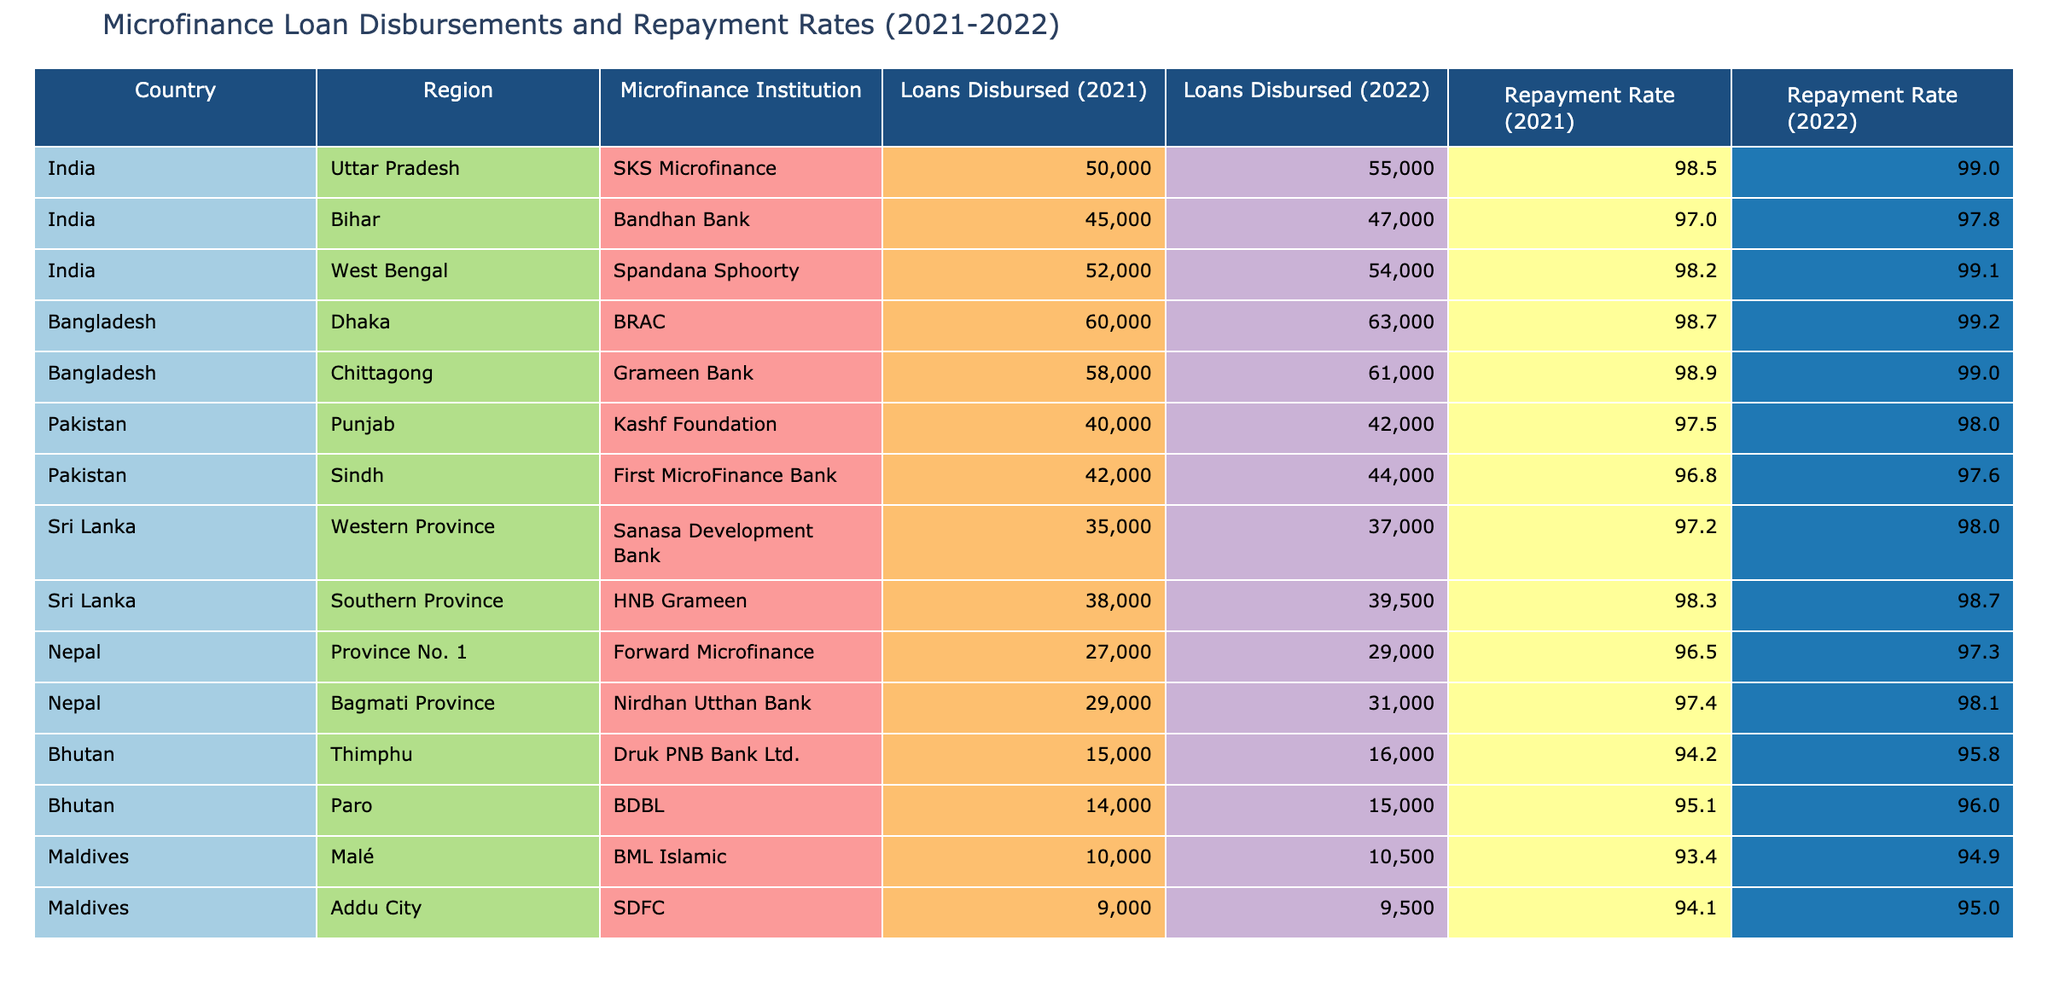What was the total amount of loans disbursed in India in 2022? To find the total amount of loans disbursed in India for 2022, we need to sum the values from the "Loans Disbursed (2022)" column for India's entries: 55,000 (Uttar Pradesh) + 47,000 (Bihar) + 54,000 (West Bengal) = 156,000.
Answer: 156,000 Which country had the highest repayment rate in 2022? To identify the country with the highest repayment rate in 2022, we need to compare the values in the "Repayment Rate (2022)" column. BRAC in Bangladesh has 99.2%, which is the highest compared to other institutions.
Answer: Bangladesh Did the repayment rate in Nepal improve from 2021 to 2022? To determine if the repayment rate improved, we need to compare the repayment rates for 2021 and 2022. For Forward Microfinance: 96.5% (2021) to 97.3% (2022), and for Nirdhan Utthan Bank: 97.4% (2021) to 98.1% (2022). Both institutions show an increase, so yes, repayment rates improved.
Answer: Yes What is the average repayment rate in Sri Lanka for 2021? To compute the average repayment rate in Sri Lanka for 2021, we take the repayment rates for the institutions listed: Sanasa Development Bank with 97.2% and HNB Grameen with 98.3%. The average is (97.2% + 98.3%) / 2 = 97.75%.
Answer: 97.75% Which region in Pakistan had a lower repayment rate in 2022? In Pakistan, we need to check the repayment rates for Punjab (98.0%) and Sindh (97.6%) from the "Repayment Rate (2022)" column. Sindh has a lower rate.
Answer: Sindh 